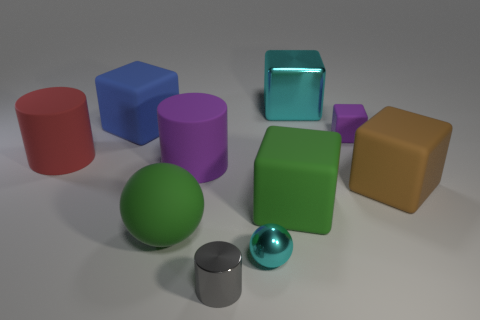How many cyan shiny objects are in front of the matte ball?
Your response must be concise. 1. What number of other things are there of the same shape as the big cyan object?
Keep it short and to the point. 4. Is the number of small brown metallic things less than the number of cyan metal cubes?
Provide a succinct answer. Yes. What is the size of the cube that is left of the large cyan cube and in front of the big blue rubber cube?
Give a very brief answer. Large. There is a block to the right of the purple object that is behind the purple matte object in front of the red thing; how big is it?
Make the answer very short. Large. The purple rubber block has what size?
Provide a succinct answer. Small. Is there any other thing that has the same material as the tiny purple object?
Keep it short and to the point. Yes. Are there any large blue things behind the cyan shiny object that is behind the big matte cylinder to the left of the purple rubber cylinder?
Your answer should be compact. No. What number of small objects are red matte objects or cyan metal balls?
Your answer should be very brief. 1. Is there anything else of the same color as the metallic cube?
Offer a very short reply. Yes. 